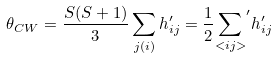<formula> <loc_0><loc_0><loc_500><loc_500>\theta _ { C W } = \frac { S ( S + 1 ) } { 3 } \sum _ { j ( i ) } h ^ { \prime } _ { i j } = \frac { 1 } { 2 } { \sum _ { < i j > } } ^ { \prime } h ^ { \prime } _ { i j }</formula> 